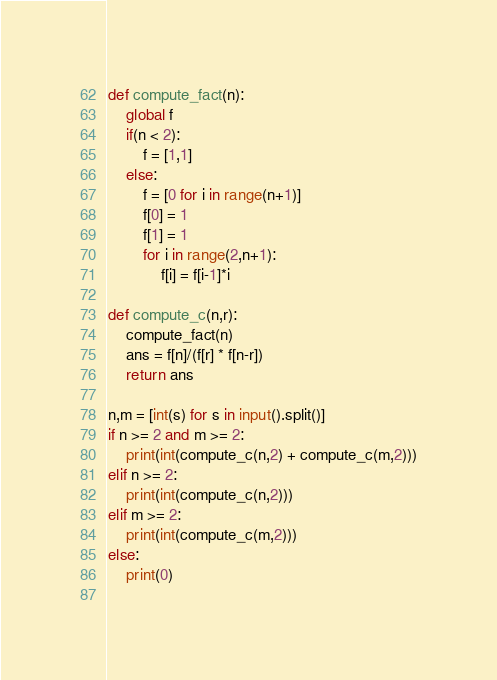<code> <loc_0><loc_0><loc_500><loc_500><_Python_>def compute_fact(n):
    global f
    if(n < 2):
        f = [1,1]
    else:
        f = [0 for i in range(n+1)]
        f[0] = 1
        f[1] = 1
        for i in range(2,n+1):
            f[i] = f[i-1]*i

def compute_c(n,r):
    compute_fact(n)
    ans = f[n]/(f[r] * f[n-r])
    return ans

n,m = [int(s) for s in input().split()]
if n >= 2 and m >= 2:
    print(int(compute_c(n,2) + compute_c(m,2)))
elif n >= 2:
    print(int(compute_c(n,2)))
elif m >= 2:
    print(int(compute_c(m,2)))
else:
    print(0)
    </code> 